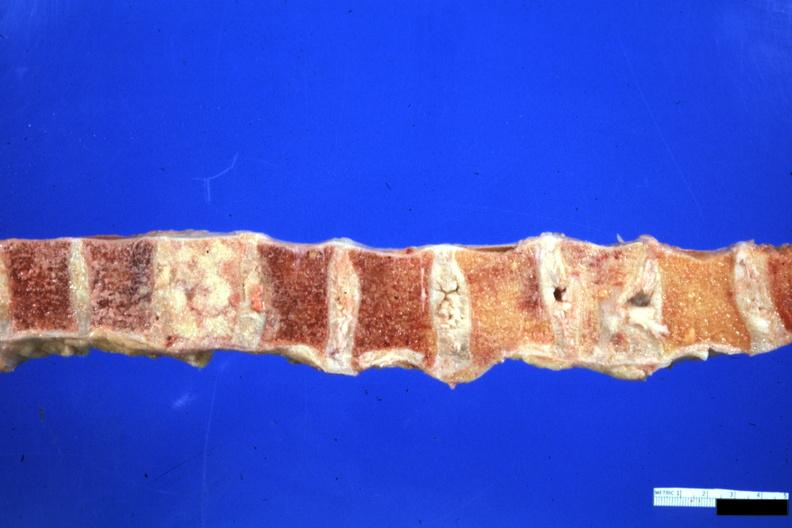what is one collapsed?
Answer the question using a single word or phrase. Vertebra and filled with neoplasm looks like breast carcinoma but an unclassified lymphoma 